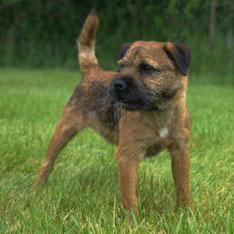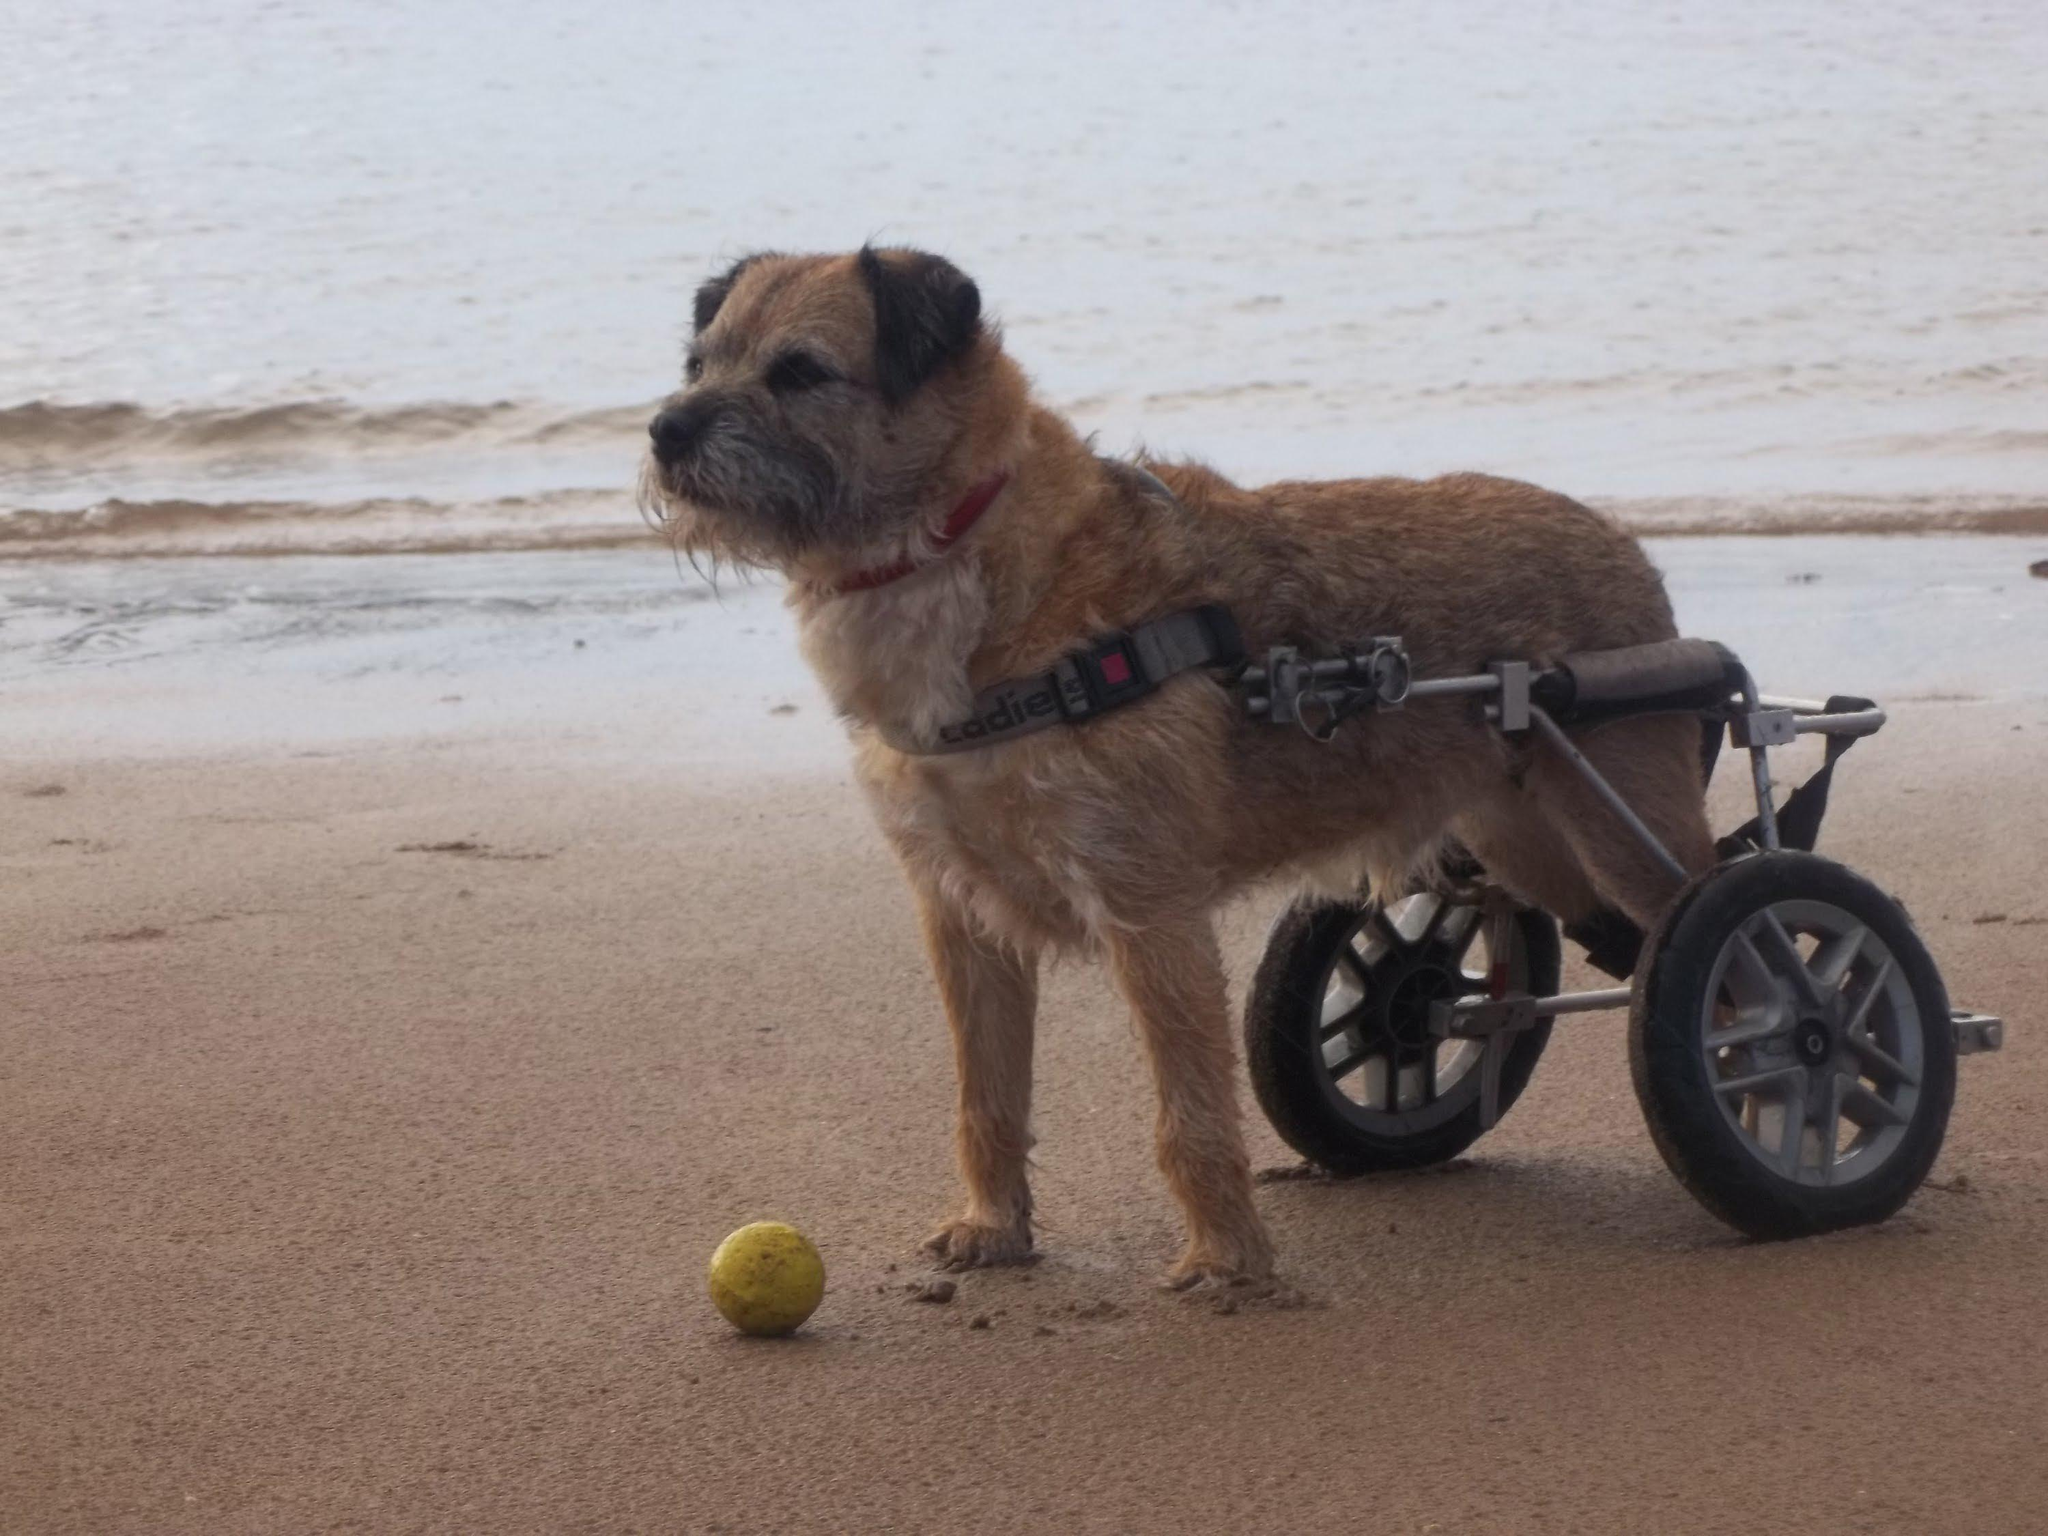The first image is the image on the left, the second image is the image on the right. Examine the images to the left and right. Is the description "One image shows a dog standing wearing a harness and facing leftward." accurate? Answer yes or no. Yes. The first image is the image on the left, the second image is the image on the right. Examine the images to the left and right. Is the description "A single dog is standing alone in the grass in the image on the left." accurate? Answer yes or no. Yes. 